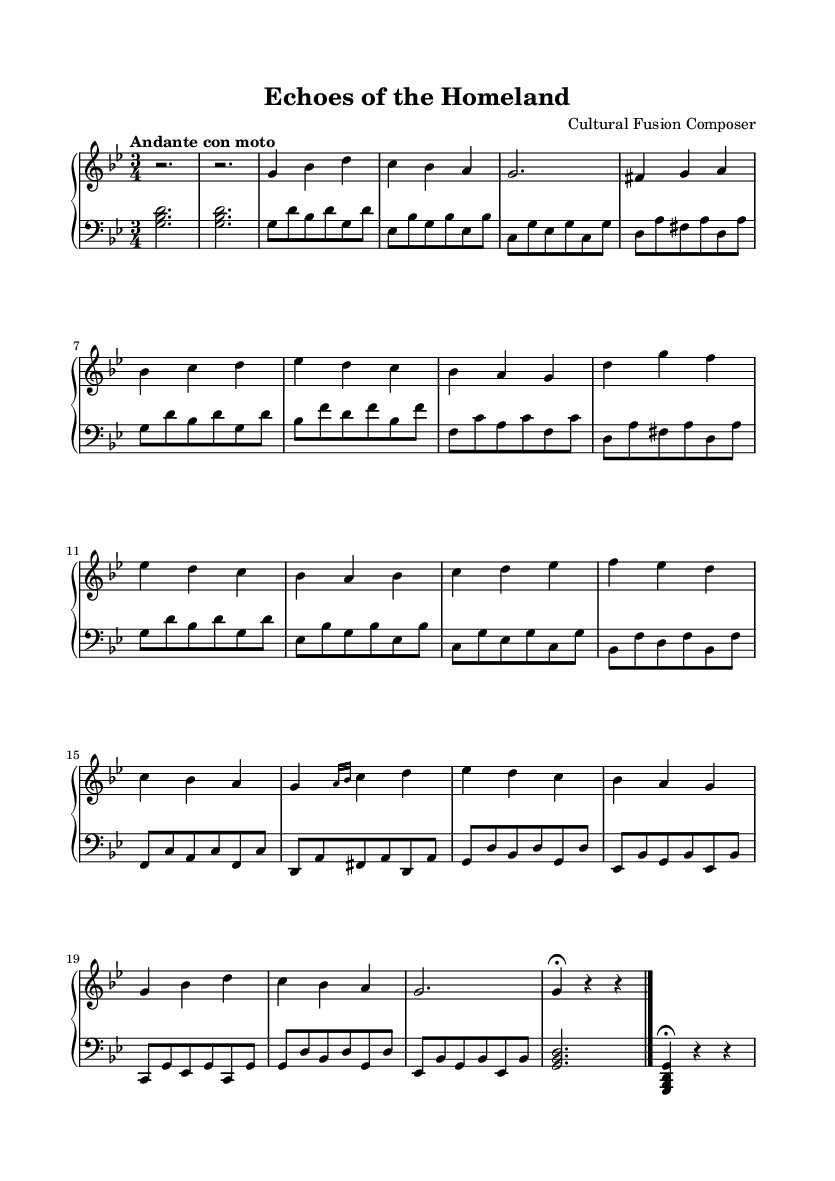What is the key signature of this music? The key signature is G minor, which has two flats. This information is determined by looking at the key signature indicated at the beginning of the staff.
Answer: G minor What is the time signature of this music? The time signature is 3/4, which indicates that there are three beats per measure. This is found at the beginning of the music, where the symbols for the time signature are displayed.
Answer: 3/4 What is the tempo marking for this piece? The tempo marking is "Andante con moto." This can be found at the start of the music just above the staff, indicating the piece should be played at a moderately slow pace but with some motion.
Answer: Andante con moto How many different themes are present in this composition? The composition features two distinct themes, labeled as Theme A and Theme B in the music. The themes can be identified by the labeling of the sections within the score.
Answer: 2 Which section of the piece serves as the introduction? The introduction consists of the first two measures where only rests are featured, setting the stage for the themes that follow. This is readily identifiable as it precedes any melodic content.
Answer: First two measures In which section does the piece revert back to the main theme? The piece returns to the main theme during the recapitulation section, as indicated by the repetition of Theme A after the development. This is determined by comparing the melodic content of the scores.
Answer: Recapitulation What type of musical form is primarily used in this composition? The composition primarily uses a ternary form (ABA), where a principal theme appears, followed by a contrasting theme, and then returns to the initial theme. This form can be recognized by its structured layout of themes in distinct sections.
Answer: Ternary form 